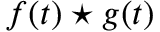Convert formula to latex. <formula><loc_0><loc_0><loc_500><loc_500>f ( t ) ^ { * } g ( t )</formula> 